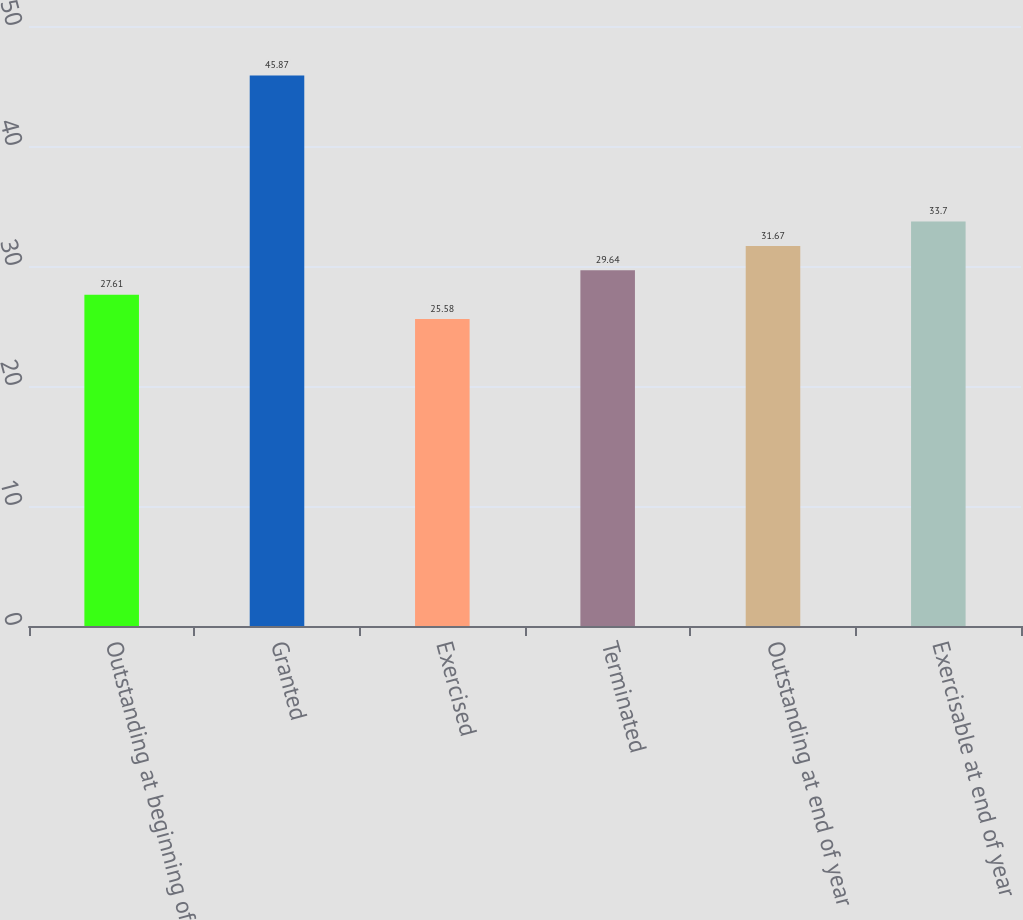<chart> <loc_0><loc_0><loc_500><loc_500><bar_chart><fcel>Outstanding at beginning of<fcel>Granted<fcel>Exercised<fcel>Terminated<fcel>Outstanding at end of year<fcel>Exercisable at end of year<nl><fcel>27.61<fcel>45.87<fcel>25.58<fcel>29.64<fcel>31.67<fcel>33.7<nl></chart> 